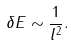<formula> <loc_0><loc_0><loc_500><loc_500>\delta E \sim \frac { 1 } { l ^ { 2 } } .</formula> 